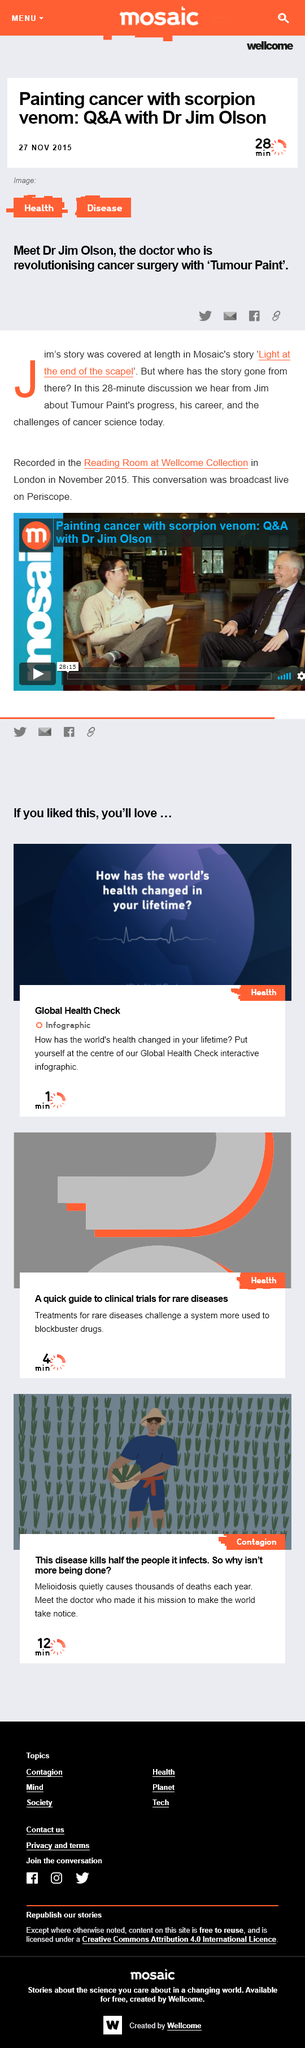Highlight a few significant elements in this photo. Doctor Jim Olson's book is titled "Light at the End of the Scalpel. The conversation between Dr. Olson and the author took place in the Reading Room at the Wellcome Collection in London. The name of the Doctor featured in the article is Doctor Jim Olson. 